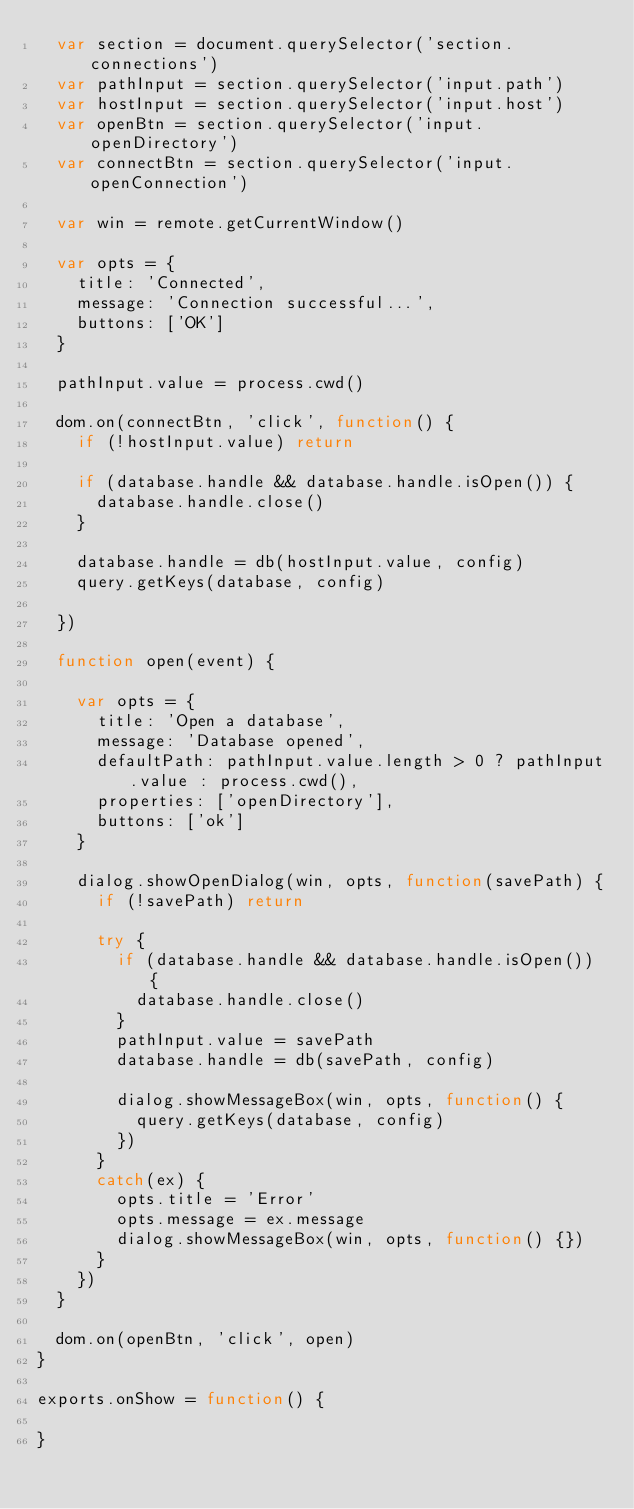Convert code to text. <code><loc_0><loc_0><loc_500><loc_500><_JavaScript_>  var section = document.querySelector('section.connections')
  var pathInput = section.querySelector('input.path')
  var hostInput = section.querySelector('input.host')
  var openBtn = section.querySelector('input.openDirectory')
  var connectBtn = section.querySelector('input.openConnection')

  var win = remote.getCurrentWindow()

  var opts = {
    title: 'Connected',
    message: 'Connection successful...',
    buttons: ['OK']
  }

  pathInput.value = process.cwd()

  dom.on(connectBtn, 'click', function() {
    if (!hostInput.value) return

    if (database.handle && database.handle.isOpen()) {
      database.handle.close()
    }

    database.handle = db(hostInput.value, config)
    query.getKeys(database, config)

  })

  function open(event) {

    var opts = {
      title: 'Open a database',
      message: 'Database opened',
      defaultPath: pathInput.value.length > 0 ? pathInput.value : process.cwd(),
      properties: ['openDirectory'],
      buttons: ['ok']
    }

    dialog.showOpenDialog(win, opts, function(savePath) {
      if (!savePath) return

      try {
        if (database.handle && database.handle.isOpen()) {
          database.handle.close()
        }
        pathInput.value = savePath
        database.handle = db(savePath, config)

        dialog.showMessageBox(win, opts, function() {
          query.getKeys(database, config)
        })
      }
      catch(ex) {
        opts.title = 'Error'
        opts.message = ex.message
        dialog.showMessageBox(win, opts, function() {})
      }
    })
  }

  dom.on(openBtn, 'click', open)
}

exports.onShow = function() {

}
</code> 